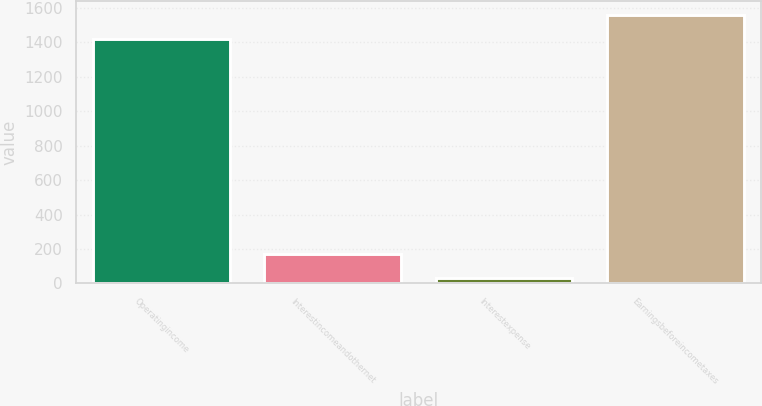Convert chart. <chart><loc_0><loc_0><loc_500><loc_500><bar_chart><fcel>Operatingincome<fcel>Interestincomeandothernet<fcel>Interestexpense<fcel>Earningsbeforeincometaxes<nl><fcel>1419.4<fcel>173.13<fcel>32.7<fcel>1559.83<nl></chart> 